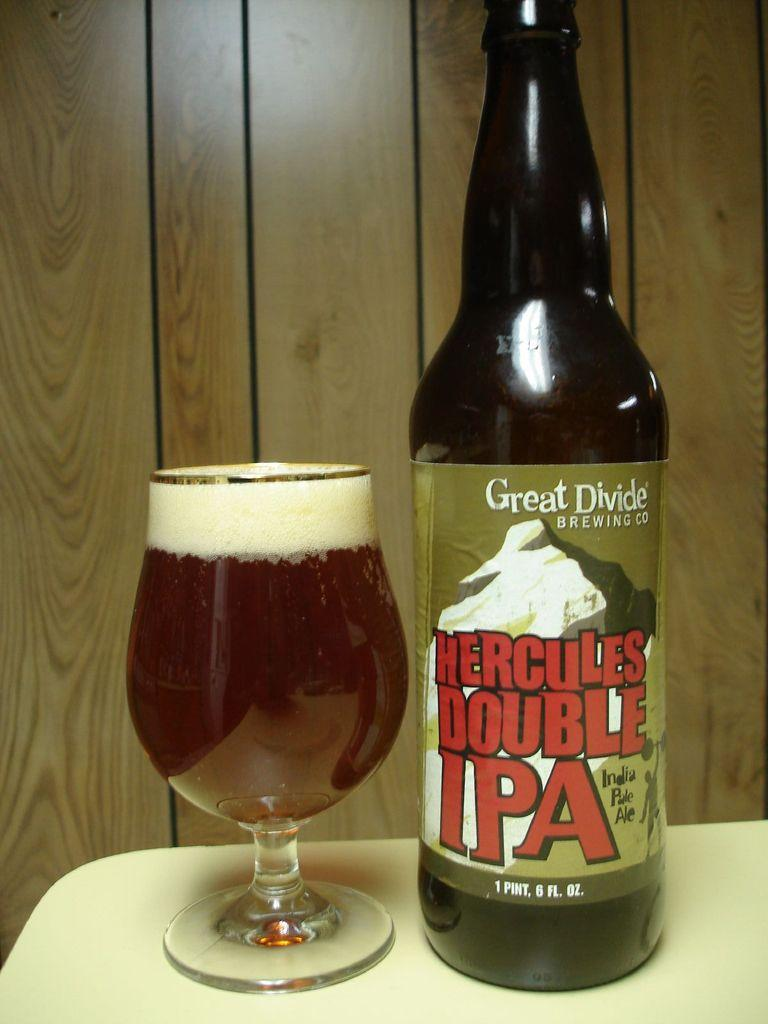<image>
Relay a brief, clear account of the picture shown. A bottle of Hercules Double IPA is next to a full glass. 